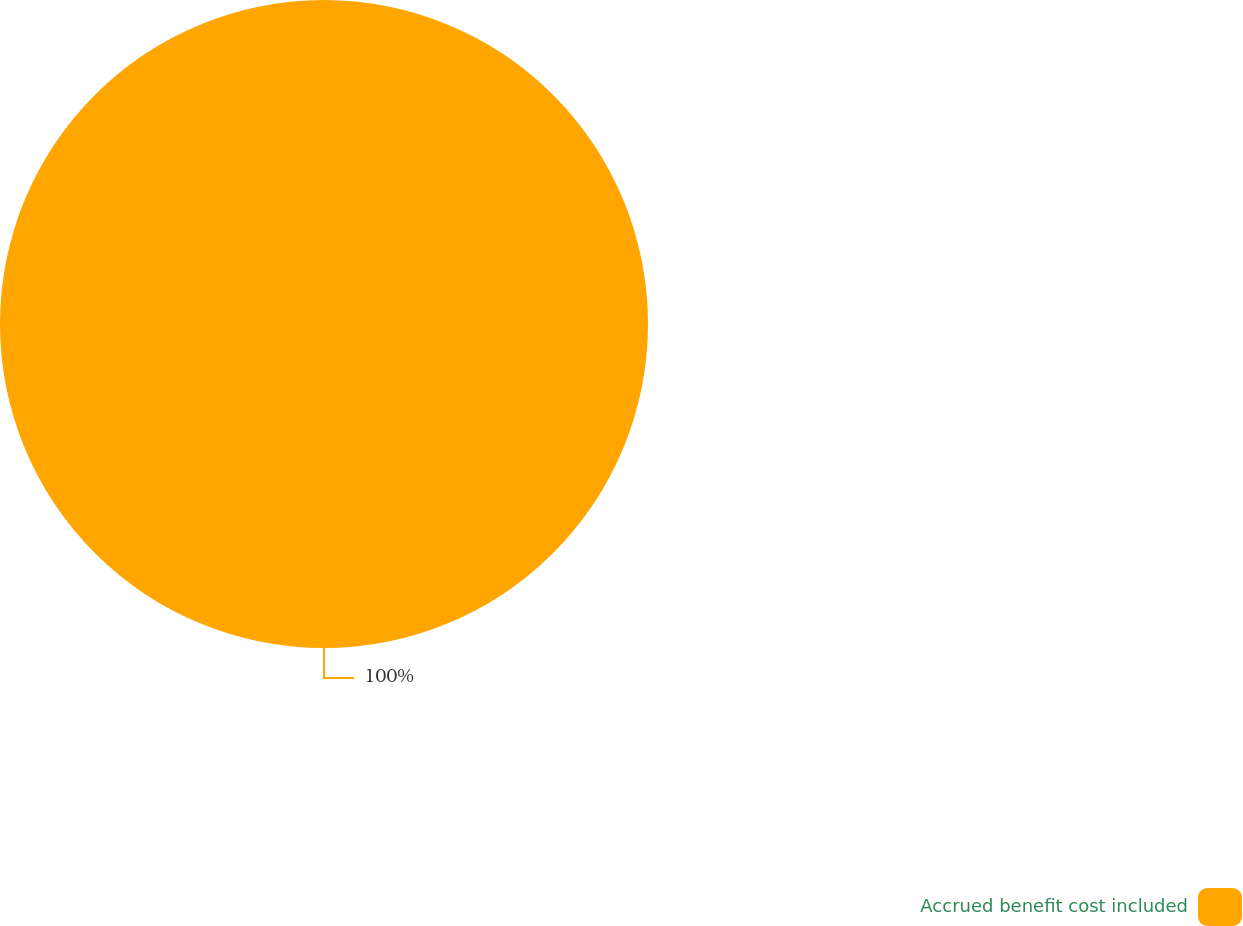Convert chart. <chart><loc_0><loc_0><loc_500><loc_500><pie_chart><fcel>Accrued benefit cost included<nl><fcel>100.0%<nl></chart> 